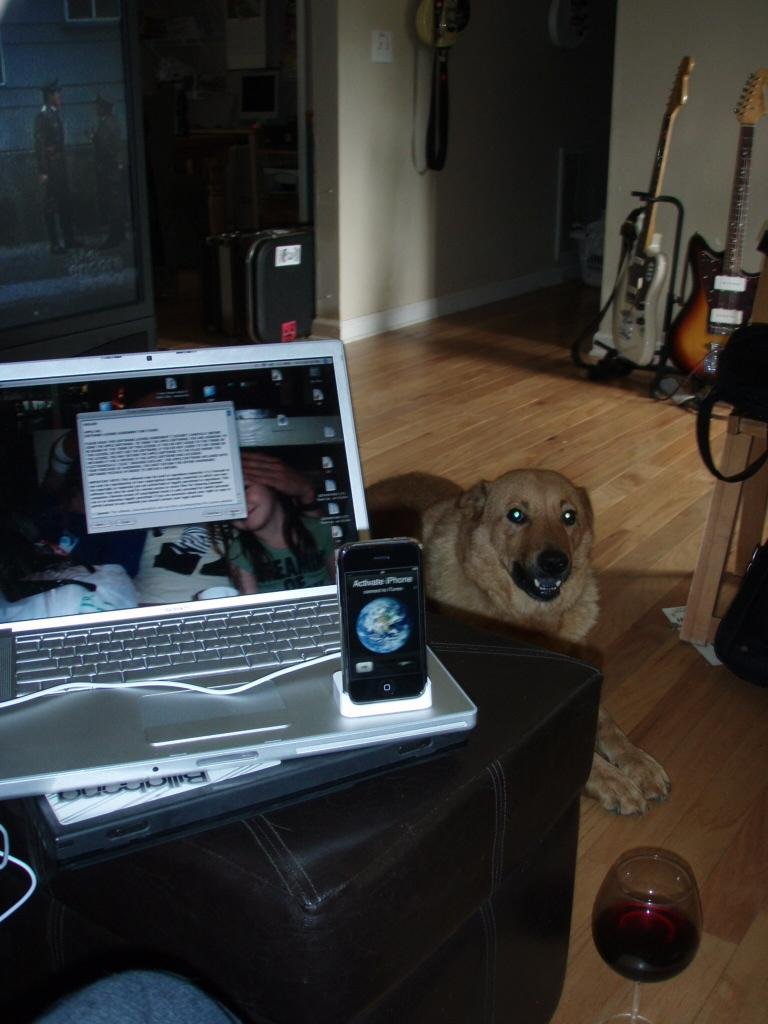What electronic devices can be seen in the image? There is a laptop and a phone in the image. Where are the laptop and phone placed? The laptop and phone are placed on a chair. What other object can be seen in the image? There is a dog and a glass in the image. What can be found in the background of the image? There are guitars in the background of the image. Can you see any cobwebs in the image? There is no mention of cobwebs in the provided facts, so we cannot determine if any are present in the image. Who is the creator of the guitars in the background? The provided facts do not mention the creator of the guitars, so we cannot determine who made them. 